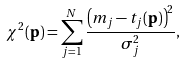Convert formula to latex. <formula><loc_0><loc_0><loc_500><loc_500>\chi ^ { 2 } ( { \mathbf p } ) = \sum _ { j = 1 } ^ { N } \frac { \left ( m _ { j } - t _ { j } ( { \mathbf p } ) \right ) ^ { 2 } } { \sigma _ { j } ^ { 2 } } ,</formula> 